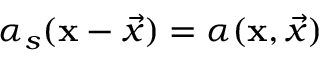Convert formula to latex. <formula><loc_0><loc_0><loc_500><loc_500>\alpha _ { s } ( x - \vec { x } ) = \alpha ( x , \vec { x } )</formula> 